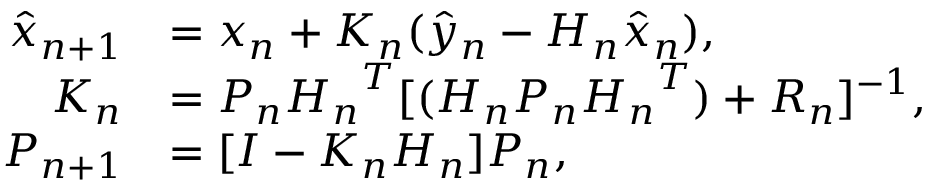<formula> <loc_0><loc_0><loc_500><loc_500>\begin{array} { r l } { \hat { x } _ { n + 1 } } & { = x _ { n } + K _ { n } ( \hat { y } _ { n } - H _ { n } \hat { x } _ { n } ) , } \\ { K _ { n } } & { = P _ { n } { H _ { n } } ^ { T } [ ( H _ { n } P _ { n } { H _ { n } } ^ { T } ) + R _ { n } ] ^ { - 1 } , } \\ { P _ { n + 1 } } & { = [ I - K _ { n } H _ { n } ] P _ { n } , } \end{array}</formula> 